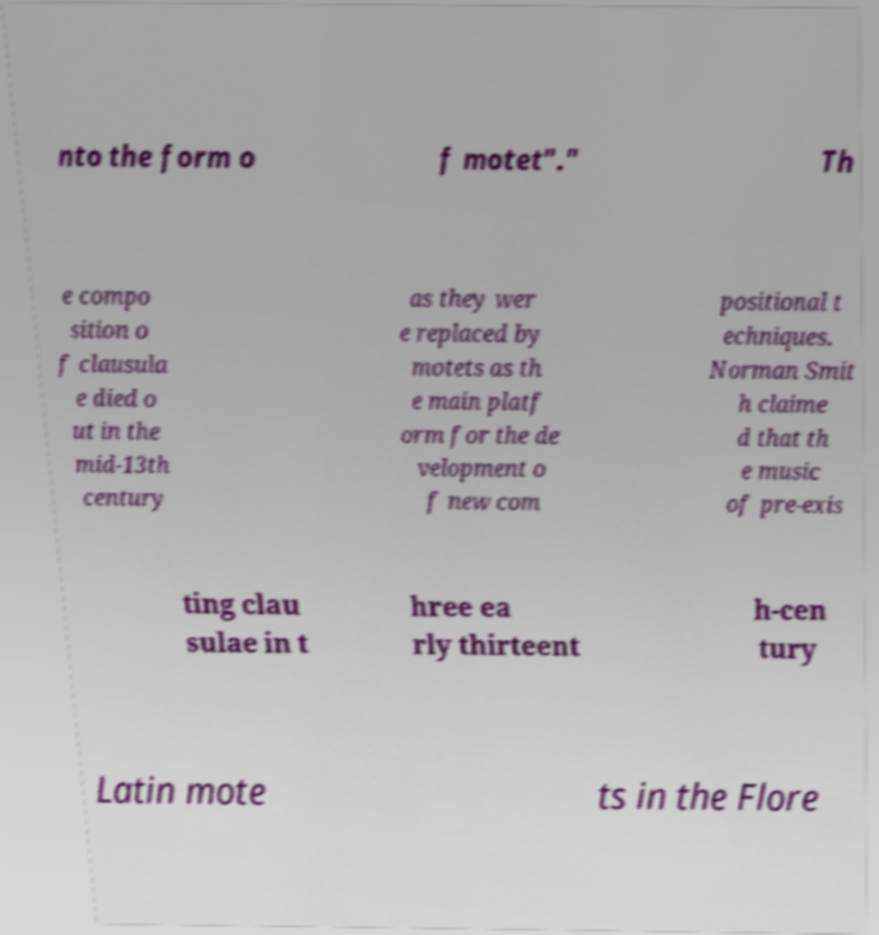Can you accurately transcribe the text from the provided image for me? nto the form o f motet"." Th e compo sition o f clausula e died o ut in the mid-13th century as they wer e replaced by motets as th e main platf orm for the de velopment o f new com positional t echniques. Norman Smit h claime d that th e music of pre-exis ting clau sulae in t hree ea rly thirteent h-cen tury Latin mote ts in the Flore 